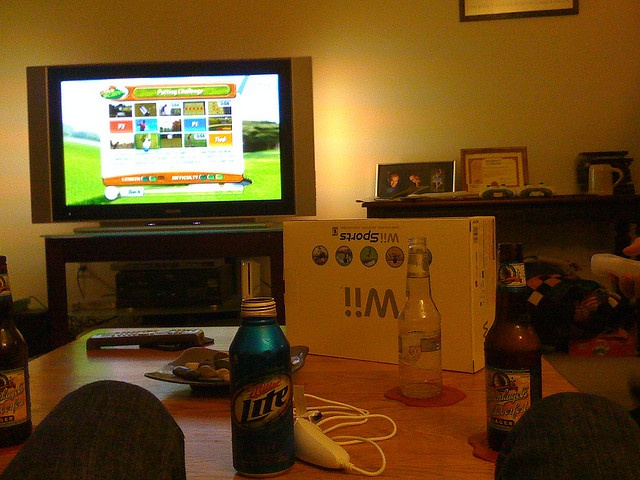Describe the objects in this image and their specific colors. I can see dining table in olive, black, and maroon tones, tv in olive, white, black, maroon, and lime tones, people in olive, black, gray, and maroon tones, bottle in olive, black, maroon, and brown tones, and bottle in olive, black, maroon, and brown tones in this image. 